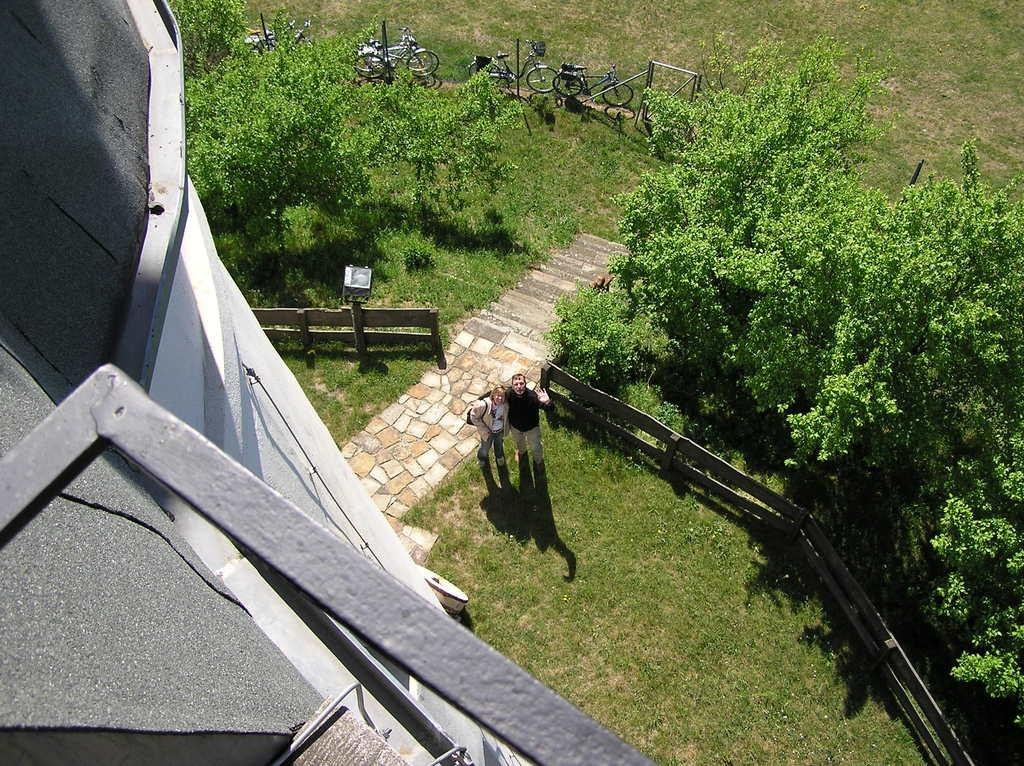What structure is visible in the image? There is a building in the image. How many people are present in the image? There are two people standing on the ground in the image. What can be seen in the background of the image? There is a fence, bicycles, trees, and metal poles in the background of the image. What type of substance is being used to paint the room in the image? There is no room or painting activity present in the image. 